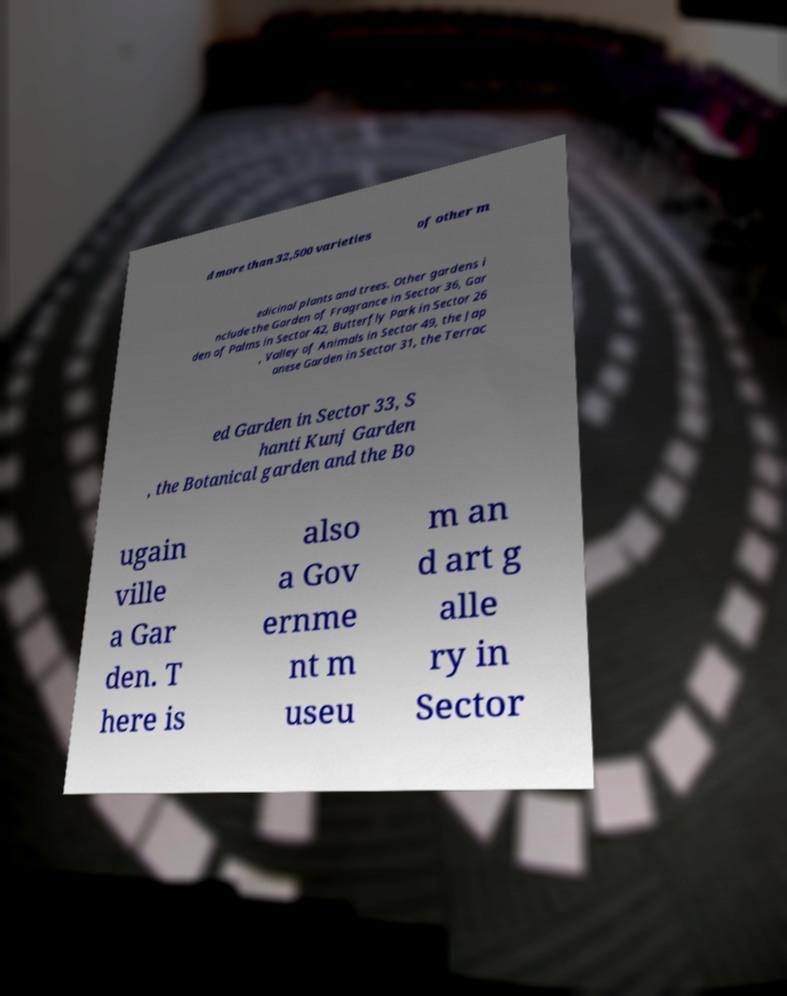Could you extract and type out the text from this image? d more than 32,500 varieties of other m edicinal plants and trees. Other gardens i nclude the Garden of Fragrance in Sector 36, Gar den of Palms in Sector 42, Butterfly Park in Sector 26 , Valley of Animals in Sector 49, the Jap anese Garden in Sector 31, the Terrac ed Garden in Sector 33, S hanti Kunj Garden , the Botanical garden and the Bo ugain ville a Gar den. T here is also a Gov ernme nt m useu m an d art g alle ry in Sector 